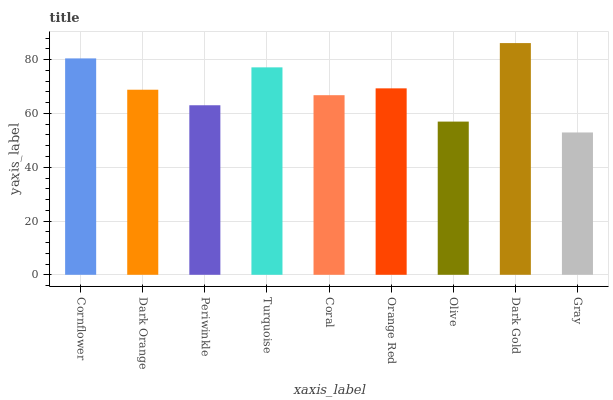Is Dark Orange the minimum?
Answer yes or no. No. Is Dark Orange the maximum?
Answer yes or no. No. Is Cornflower greater than Dark Orange?
Answer yes or no. Yes. Is Dark Orange less than Cornflower?
Answer yes or no. Yes. Is Dark Orange greater than Cornflower?
Answer yes or no. No. Is Cornflower less than Dark Orange?
Answer yes or no. No. Is Dark Orange the high median?
Answer yes or no. Yes. Is Dark Orange the low median?
Answer yes or no. Yes. Is Orange Red the high median?
Answer yes or no. No. Is Olive the low median?
Answer yes or no. No. 